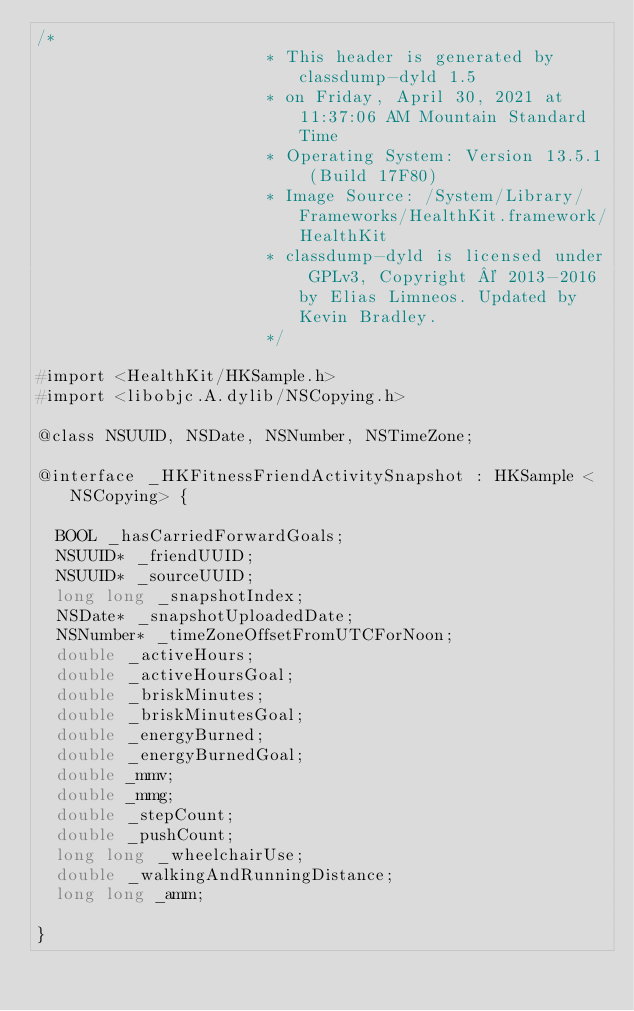<code> <loc_0><loc_0><loc_500><loc_500><_C_>/*
                       * This header is generated by classdump-dyld 1.5
                       * on Friday, April 30, 2021 at 11:37:06 AM Mountain Standard Time
                       * Operating System: Version 13.5.1 (Build 17F80)
                       * Image Source: /System/Library/Frameworks/HealthKit.framework/HealthKit
                       * classdump-dyld is licensed under GPLv3, Copyright © 2013-2016 by Elias Limneos. Updated by Kevin Bradley.
                       */

#import <HealthKit/HKSample.h>
#import <libobjc.A.dylib/NSCopying.h>

@class NSUUID, NSDate, NSNumber, NSTimeZone;

@interface _HKFitnessFriendActivitySnapshot : HKSample <NSCopying> {

	BOOL _hasCarriedForwardGoals;
	NSUUID* _friendUUID;
	NSUUID* _sourceUUID;
	long long _snapshotIndex;
	NSDate* _snapshotUploadedDate;
	NSNumber* _timeZoneOffsetFromUTCForNoon;
	double _activeHours;
	double _activeHoursGoal;
	double _briskMinutes;
	double _briskMinutesGoal;
	double _energyBurned;
	double _energyBurnedGoal;
	double _mmv;
	double _mmg;
	double _stepCount;
	double _pushCount;
	long long _wheelchairUse;
	double _walkingAndRunningDistance;
	long long _amm;

}
</code> 